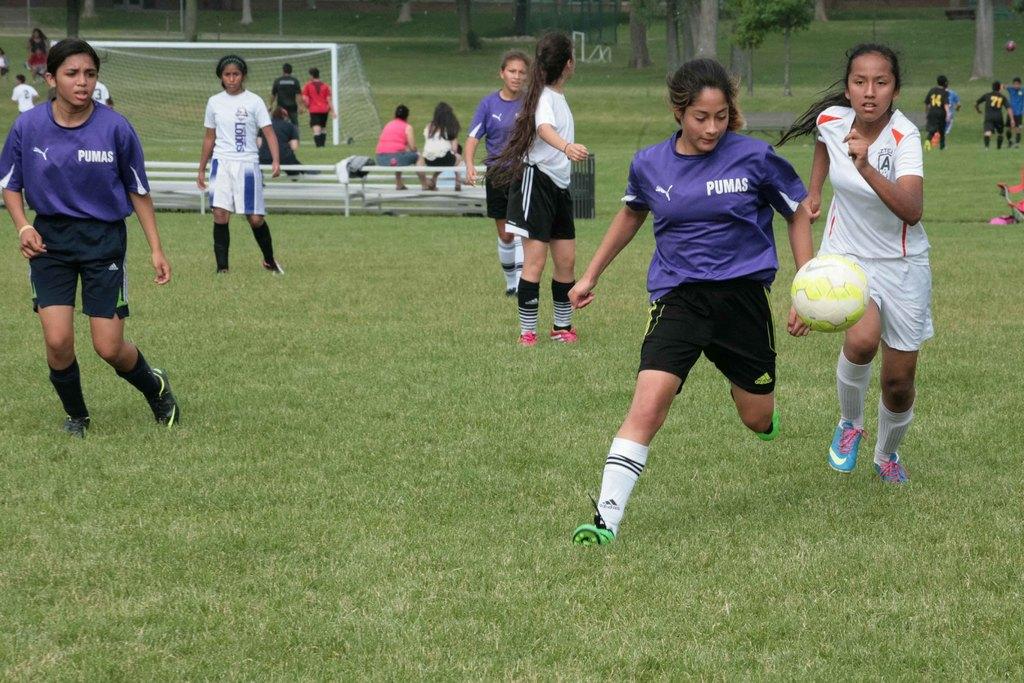What brand is on the blue jersey?
Ensure brevity in your answer.  Puma. How many puma jersey are there?
Your response must be concise. 3. 